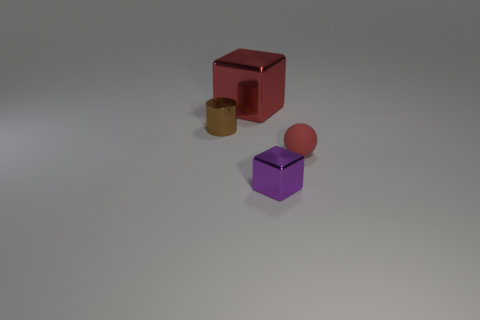Do the tiny ball and the small brown object have the same material?
Provide a short and direct response. No. What color is the object that is on the right side of the cube that is on the right side of the big object?
Offer a very short reply. Red. What is the size of the purple block that is the same material as the cylinder?
Your answer should be compact. Small. What number of tiny brown metal things are the same shape as the large red thing?
Ensure brevity in your answer.  0. How many things are either things on the left side of the red metal thing or objects behind the small brown metal thing?
Offer a very short reply. 2. What number of tiny metal cylinders are on the right side of the metallic cube in front of the brown shiny cylinder?
Your response must be concise. 0. There is a metal thing in front of the matte sphere; is its shape the same as the red thing in front of the small brown metallic cylinder?
Provide a short and direct response. No. There is a big shiny object that is the same color as the ball; what shape is it?
Your answer should be compact. Cube. Are there any large red things that have the same material as the tiny cube?
Ensure brevity in your answer.  Yes. What number of metal things are either big red objects or small spheres?
Your response must be concise. 1. 